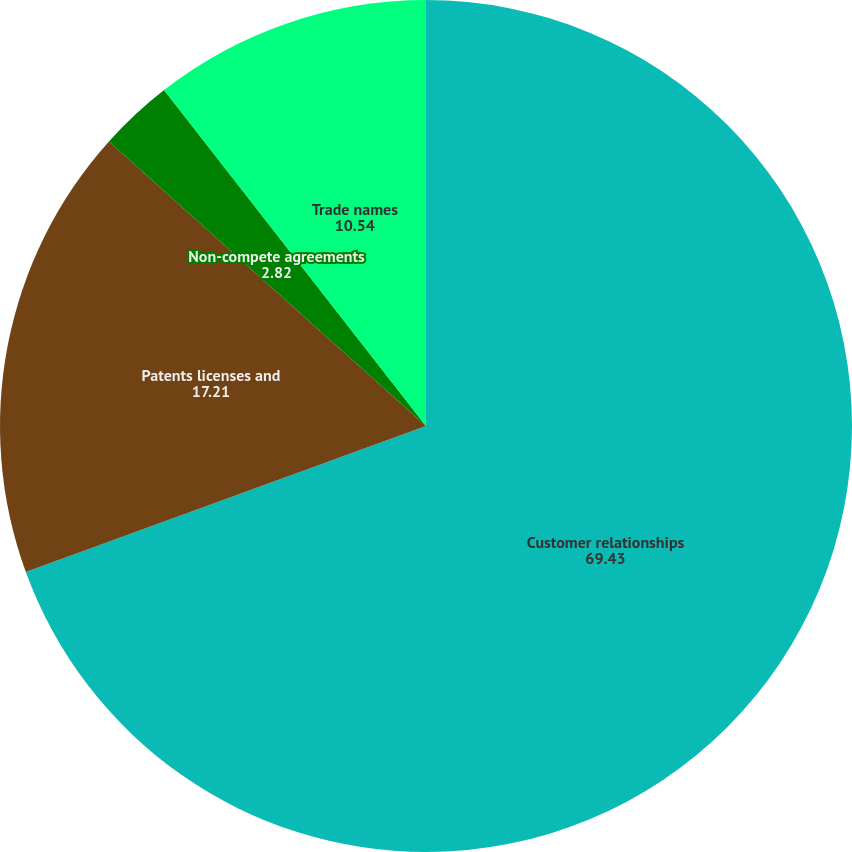<chart> <loc_0><loc_0><loc_500><loc_500><pie_chart><fcel>Customer relationships<fcel>Patents licenses and<fcel>Non-compete agreements<fcel>Trade names<nl><fcel>69.43%<fcel>17.21%<fcel>2.82%<fcel>10.54%<nl></chart> 